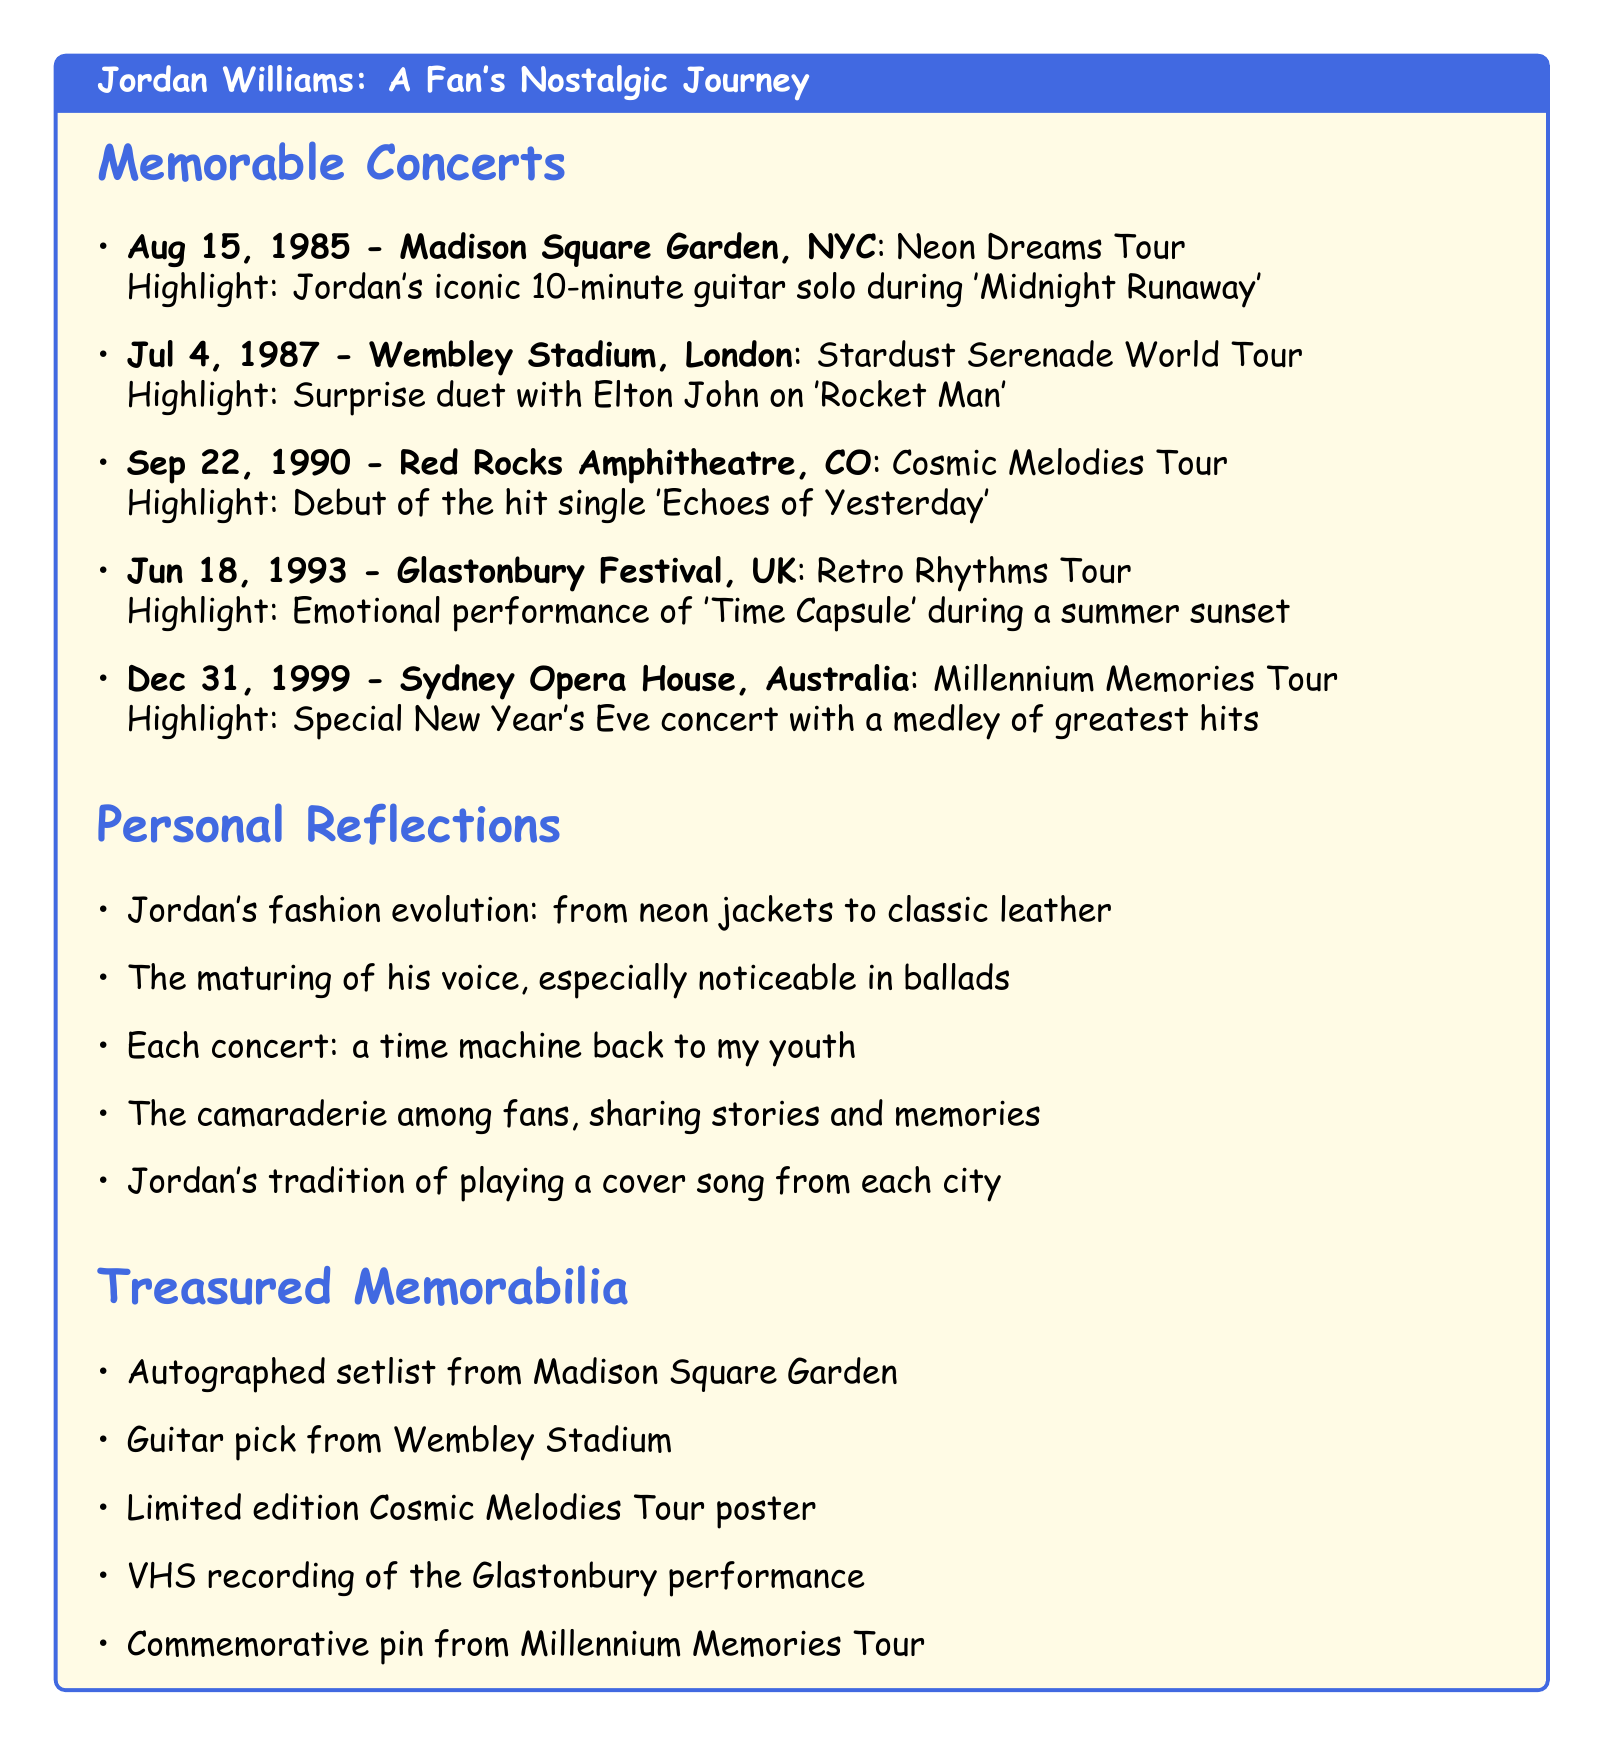What date was the concert at Madison Square Garden? The concert at Madison Square Garden took place on August 15, 1985.
Answer: August 15, 1985 Who performed a surprise duet with Jordan at Wembley Stadium? The surprise duet at Wembley Stadium was with Elton John.
Answer: Elton John What is the title of the hit single debuted at Red Rocks Amphitheatre? The debut single at Red Rocks Amphitheatre was 'Echoes of Yesterday.'
Answer: Echoes of Yesterday Which tour featured an emotional performance during a summer sunset at Glastonbury? The emotional performance during a summer sunset occurred during the Retro Rhythms Tour.
Answer: Retro Rhythms Tour How many concert tickets are listed in the document? The document lists a total of five concert tickets.
Answer: Five What is a notable tradition of Jordan at his concerts? Jordan has a tradition of playing a cover song from the city he's performing in.
Answer: Cover song from the city Which memorabilia is associated with the Millennium Memories Tour? The commemorative pin is associated with the Millennium Memories Tour.
Answer: Commemorative pin During which tour did Jordan perform at the Sydney Opera House? He performed at the Sydney Opera House during the Millennium Memories Tour.
Answer: Millennium Memories Tour What color is the header of the document? The header color in the document is retro blue.
Answer: Retro blue 